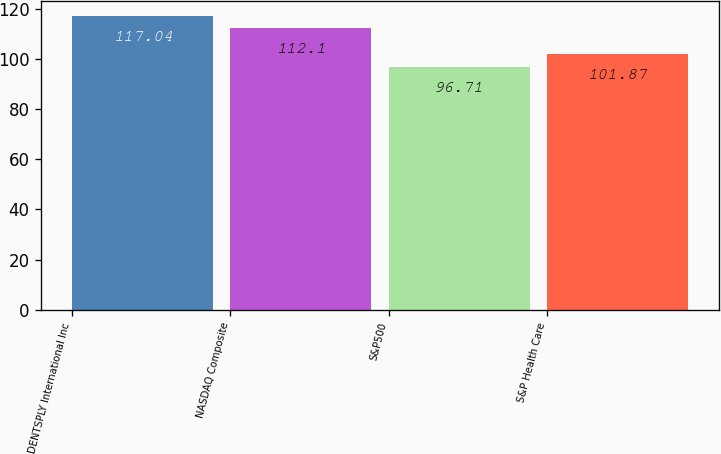Convert chart to OTSL. <chart><loc_0><loc_0><loc_500><loc_500><bar_chart><fcel>DENTSPLY International Inc<fcel>NASDAQ Composite<fcel>S&P500<fcel>S&P Health Care<nl><fcel>117.04<fcel>112.1<fcel>96.71<fcel>101.87<nl></chart> 